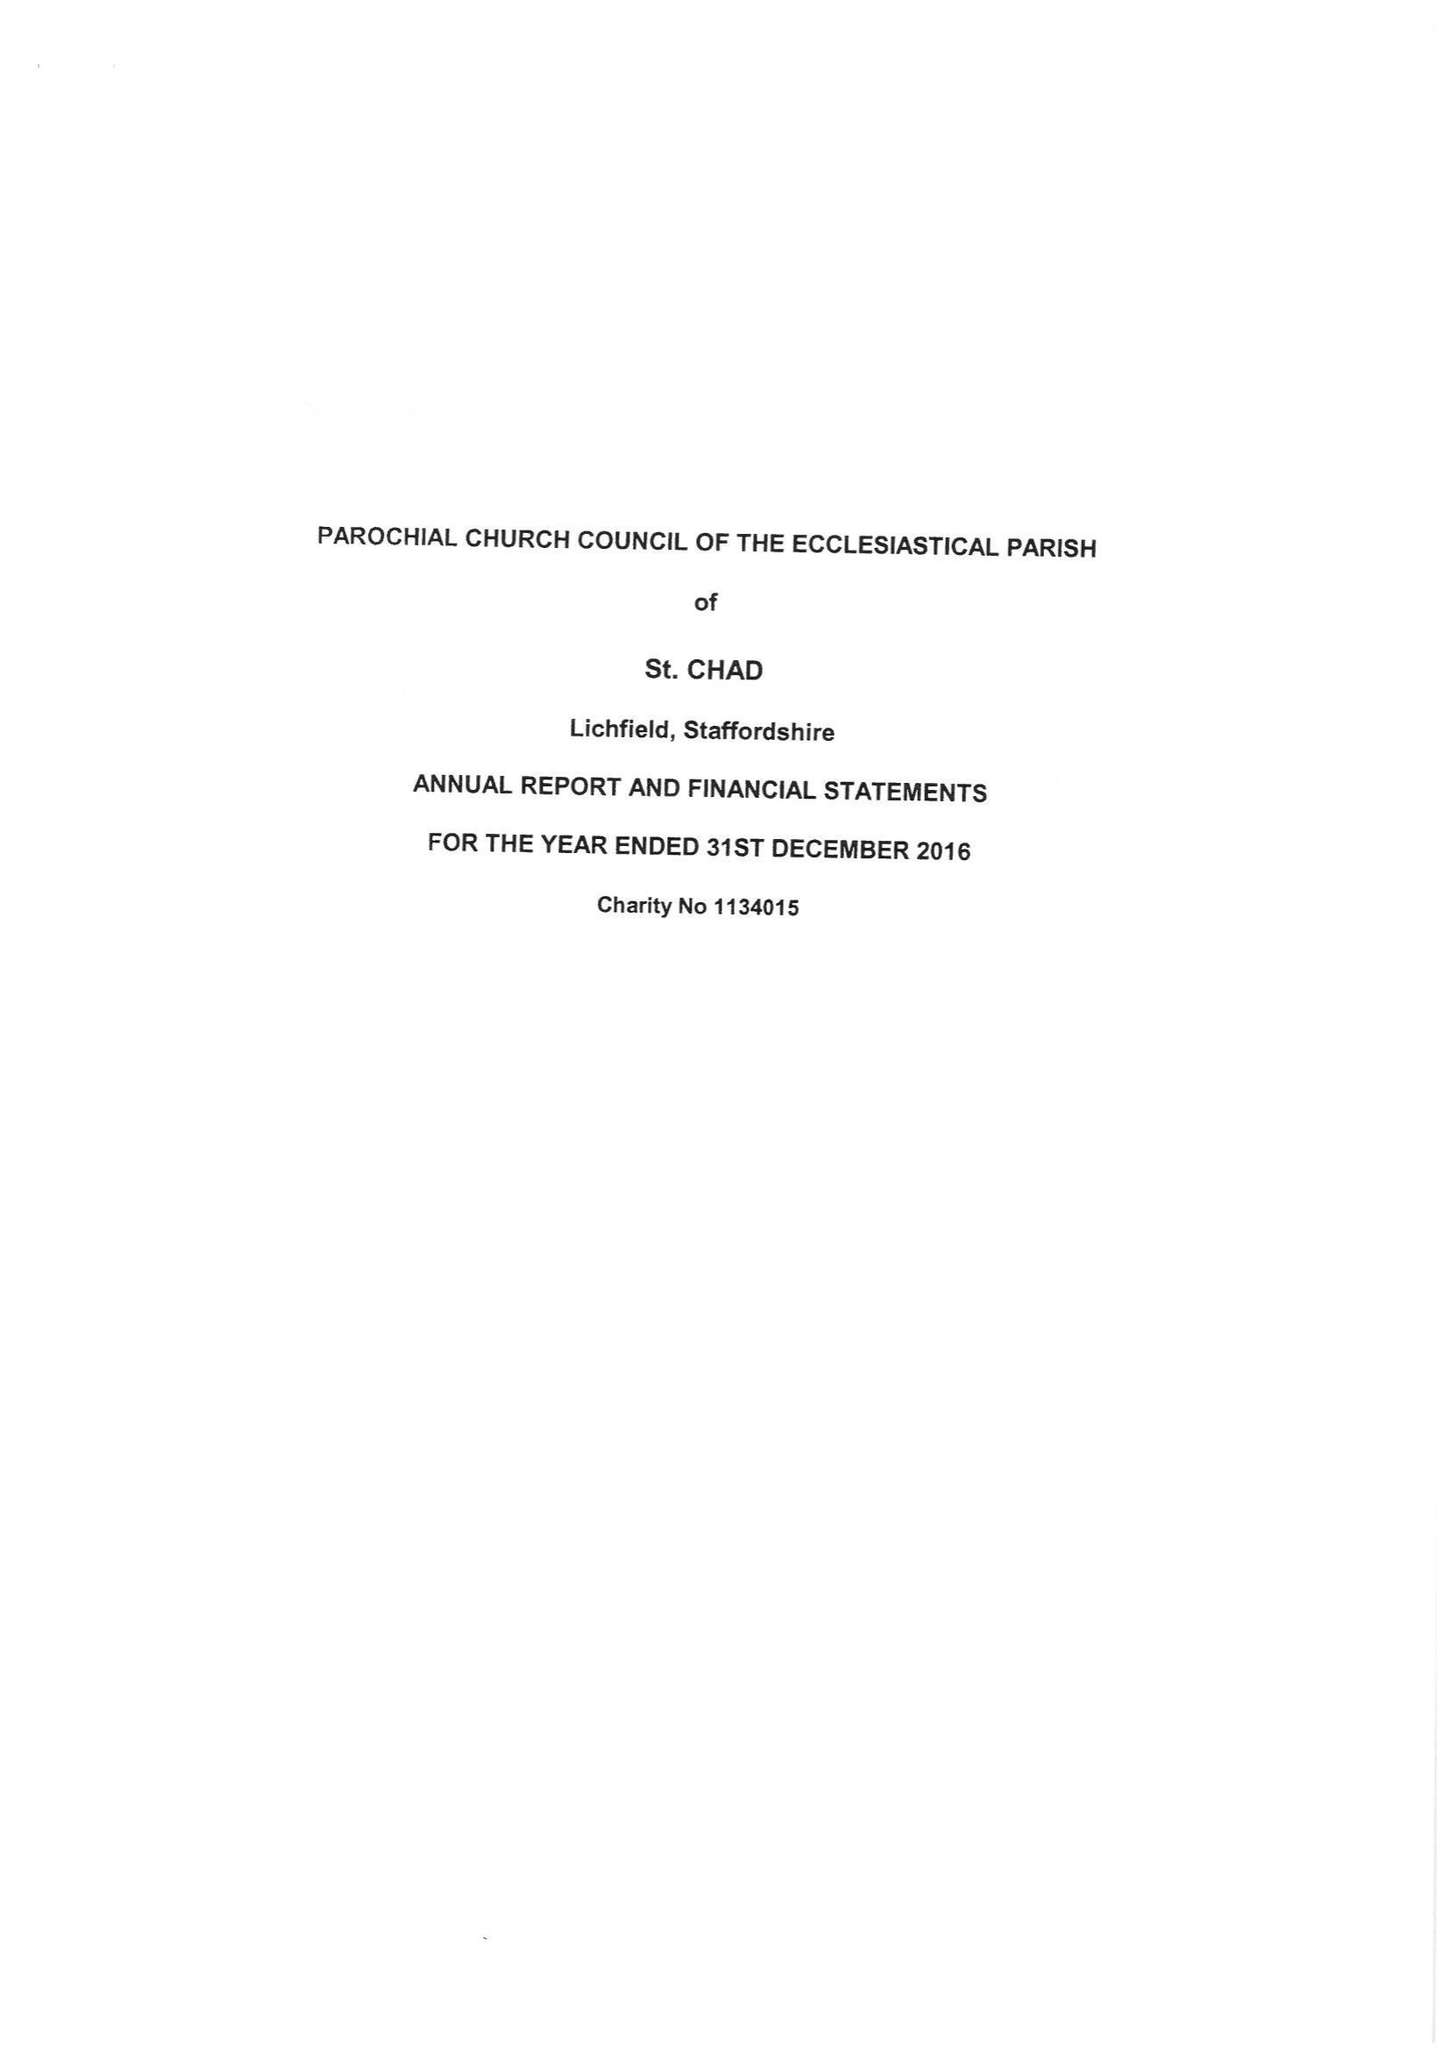What is the value for the charity_name?
Answer the question using a single word or phrase. The Parochial Church Council Of The Ecclesiastical Parish Of St. Chad, Lichfield 